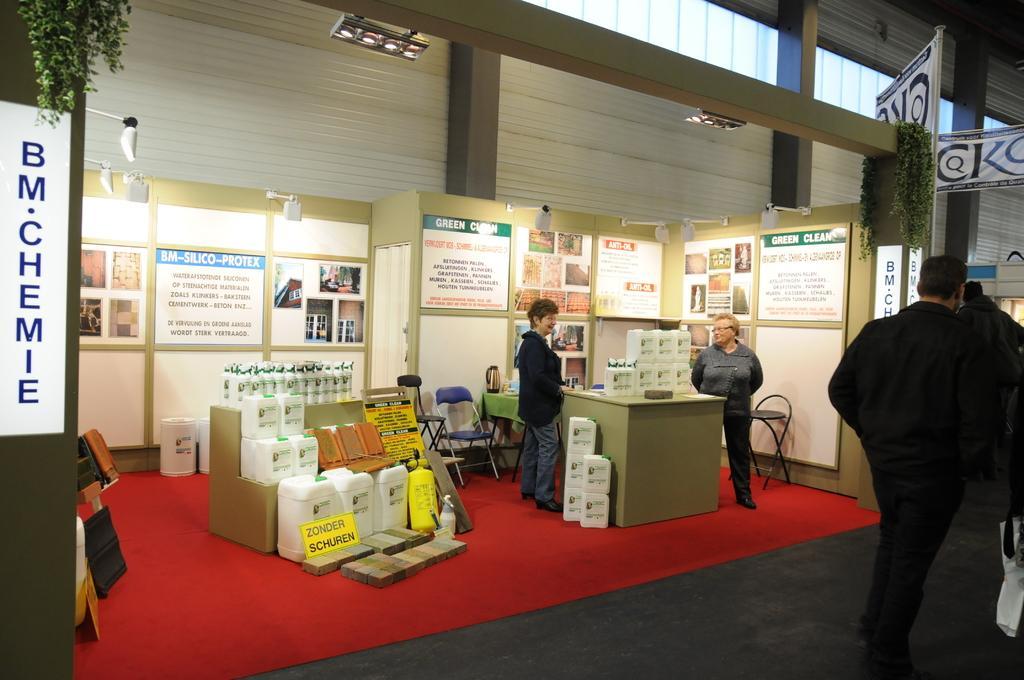In one or two sentences, can you explain what this image depicts? In this image I can see some people. I can see some objects on the floor. At the top I can see the lights. 